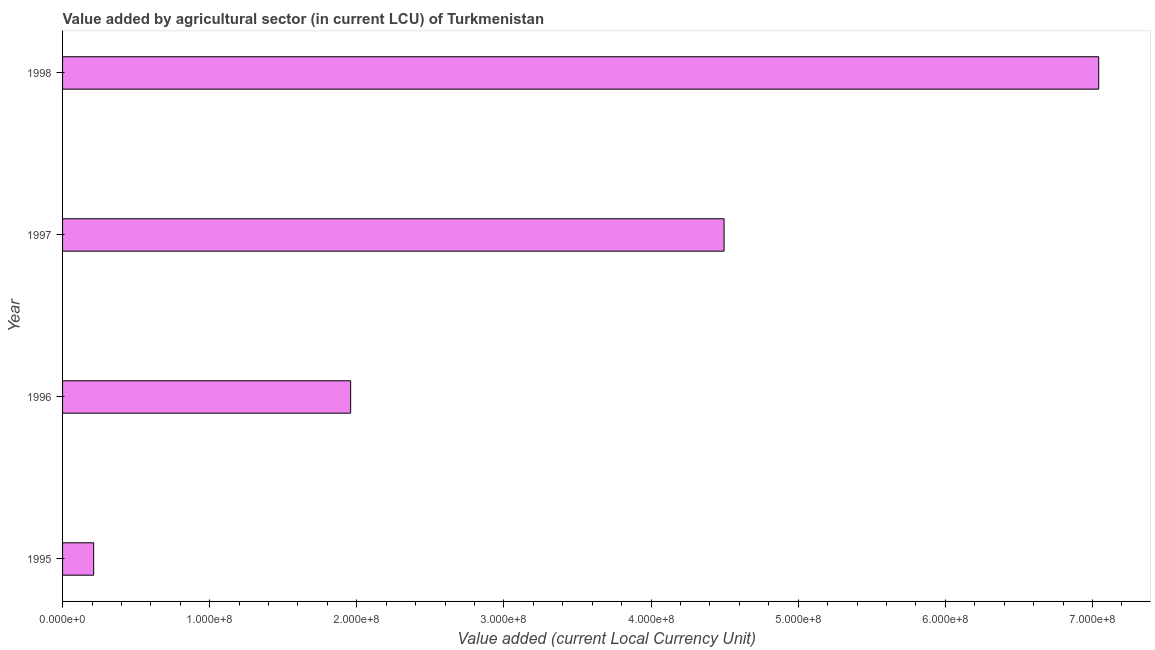What is the title of the graph?
Your answer should be very brief. Value added by agricultural sector (in current LCU) of Turkmenistan. What is the label or title of the X-axis?
Offer a terse response. Value added (current Local Currency Unit). What is the label or title of the Y-axis?
Offer a very short reply. Year. What is the value added by agriculture sector in 1998?
Provide a short and direct response. 7.04e+08. Across all years, what is the maximum value added by agriculture sector?
Ensure brevity in your answer.  7.04e+08. Across all years, what is the minimum value added by agriculture sector?
Provide a short and direct response. 2.11e+07. In which year was the value added by agriculture sector maximum?
Give a very brief answer. 1998. In which year was the value added by agriculture sector minimum?
Provide a succinct answer. 1995. What is the sum of the value added by agriculture sector?
Your answer should be very brief. 1.37e+09. What is the difference between the value added by agriculture sector in 1996 and 1997?
Your response must be concise. -2.54e+08. What is the average value added by agriculture sector per year?
Your response must be concise. 3.43e+08. What is the median value added by agriculture sector?
Give a very brief answer. 3.23e+08. In how many years, is the value added by agriculture sector greater than 380000000 LCU?
Give a very brief answer. 2. What is the ratio of the value added by agriculture sector in 1995 to that in 1996?
Ensure brevity in your answer.  0.11. Is the value added by agriculture sector in 1995 less than that in 1998?
Make the answer very short. Yes. What is the difference between the highest and the second highest value added by agriculture sector?
Your answer should be compact. 2.55e+08. Is the sum of the value added by agriculture sector in 1995 and 1998 greater than the maximum value added by agriculture sector across all years?
Your answer should be very brief. Yes. What is the difference between the highest and the lowest value added by agriculture sector?
Keep it short and to the point. 6.83e+08. How many bars are there?
Make the answer very short. 4. Are all the bars in the graph horizontal?
Offer a very short reply. Yes. What is the difference between two consecutive major ticks on the X-axis?
Provide a short and direct response. 1.00e+08. What is the Value added (current Local Currency Unit) in 1995?
Ensure brevity in your answer.  2.11e+07. What is the Value added (current Local Currency Unit) of 1996?
Ensure brevity in your answer.  1.96e+08. What is the Value added (current Local Currency Unit) in 1997?
Ensure brevity in your answer.  4.50e+08. What is the Value added (current Local Currency Unit) of 1998?
Make the answer very short. 7.04e+08. What is the difference between the Value added (current Local Currency Unit) in 1995 and 1996?
Make the answer very short. -1.75e+08. What is the difference between the Value added (current Local Currency Unit) in 1995 and 1997?
Your answer should be very brief. -4.28e+08. What is the difference between the Value added (current Local Currency Unit) in 1995 and 1998?
Ensure brevity in your answer.  -6.83e+08. What is the difference between the Value added (current Local Currency Unit) in 1996 and 1997?
Your answer should be very brief. -2.54e+08. What is the difference between the Value added (current Local Currency Unit) in 1996 and 1998?
Provide a succinct answer. -5.08e+08. What is the difference between the Value added (current Local Currency Unit) in 1997 and 1998?
Make the answer very short. -2.55e+08. What is the ratio of the Value added (current Local Currency Unit) in 1995 to that in 1996?
Your answer should be very brief. 0.11. What is the ratio of the Value added (current Local Currency Unit) in 1995 to that in 1997?
Provide a succinct answer. 0.05. What is the ratio of the Value added (current Local Currency Unit) in 1995 to that in 1998?
Make the answer very short. 0.03. What is the ratio of the Value added (current Local Currency Unit) in 1996 to that in 1997?
Make the answer very short. 0.43. What is the ratio of the Value added (current Local Currency Unit) in 1996 to that in 1998?
Your response must be concise. 0.28. What is the ratio of the Value added (current Local Currency Unit) in 1997 to that in 1998?
Offer a terse response. 0.64. 